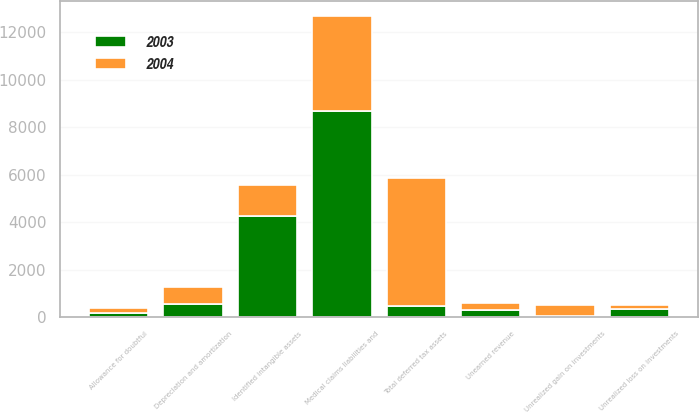<chart> <loc_0><loc_0><loc_500><loc_500><stacked_bar_chart><ecel><fcel>Medical claims liabilities and<fcel>Allowance for doubtful<fcel>Depreciation and amortization<fcel>Unearned revenue<fcel>Unrealized loss on investments<fcel>Total deferred tax assets<fcel>Identified intangible assets<fcel>Unrealized gain on investments<nl><fcel>2003<fcel>8696<fcel>175<fcel>541<fcel>304<fcel>353<fcel>472<fcel>4286<fcel>41<nl><fcel>2004<fcel>3992<fcel>230<fcel>720<fcel>279<fcel>156<fcel>5377<fcel>1288<fcel>472<nl></chart> 